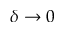<formula> <loc_0><loc_0><loc_500><loc_500>\delta \rightarrow 0</formula> 